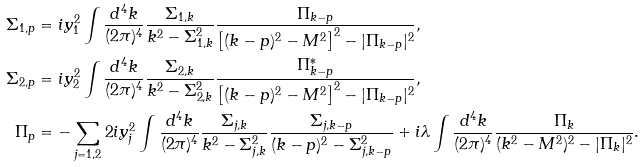<formula> <loc_0><loc_0><loc_500><loc_500>\Sigma _ { 1 , p } & = i y _ { 1 } ^ { 2 } \int \frac { d ^ { 4 } k } { ( 2 \pi ) ^ { 4 } } \frac { \Sigma _ { 1 , k } } { k ^ { 2 } - \Sigma _ { 1 , k } ^ { 2 } } \frac { \Pi _ { k - p } } { \left [ ( k - p ) ^ { 2 } - M ^ { 2 } \right ] ^ { 2 } - | \Pi _ { k - p } | ^ { 2 } } , \\ \Sigma _ { 2 , p } & = i y _ { 2 } ^ { 2 } \int \frac { d ^ { 4 } k } { ( 2 \pi ) ^ { 4 } } \frac { \Sigma _ { 2 , k } } { k ^ { 2 } - \Sigma _ { 2 , k } ^ { 2 } } \frac { \Pi ^ { * } _ { k - p } } { \left [ ( k - p ) ^ { 2 } - M ^ { 2 } \right ] ^ { 2 } - | \Pi _ { k - p } | ^ { 2 } } , \\ \Pi _ { p } & = - \sum _ { j = 1 , 2 } 2 i y _ { j } ^ { 2 } \int \frac { d ^ { 4 } k } { ( 2 \pi ) ^ { 4 } } \frac { \Sigma _ { j , k } } { k ^ { 2 } - \Sigma _ { j , k } ^ { 2 } } \frac { \Sigma _ { j , k - p } } { ( k - p ) ^ { 2 } - \Sigma _ { j , k - p } ^ { 2 } } + i \lambda \int \frac { d ^ { 4 } k } { ( 2 \pi ) ^ { 4 } } \frac { \Pi _ { k } } { ( k ^ { 2 } - M ^ { 2 } ) ^ { 2 } - | \Pi _ { k } | ^ { 2 } } .</formula> 